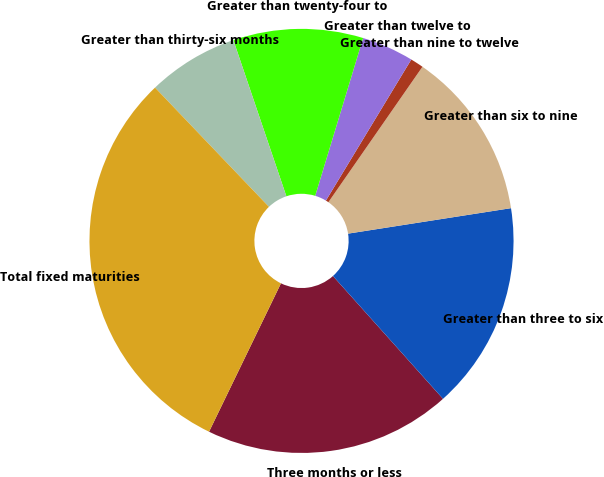<chart> <loc_0><loc_0><loc_500><loc_500><pie_chart><fcel>Three months or less<fcel>Greater than three to six<fcel>Greater than six to nine<fcel>Greater than nine to twelve<fcel>Greater than twelve to<fcel>Greater than twenty-four to<fcel>Greater than thirty-six months<fcel>Total fixed maturities<nl><fcel>18.81%<fcel>15.84%<fcel>12.87%<fcel>1.0%<fcel>3.97%<fcel>9.9%<fcel>6.93%<fcel>30.68%<nl></chart> 